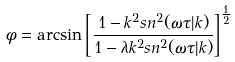Convert formula to latex. <formula><loc_0><loc_0><loc_500><loc_500>\phi = \arcsin { \left [ \frac { 1 - k ^ { 2 } s n ^ { 2 } ( \omega \tau | k ) } { 1 - \lambda k ^ { 2 } s n ^ { 2 } ( \omega \tau | k ) } \right ] } ^ { \frac { 1 } { 2 } }</formula> 